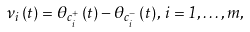Convert formula to latex. <formula><loc_0><loc_0><loc_500><loc_500>\nu _ { i } \left ( t \right ) = \theta _ { c _ { i } ^ { + } } \left ( t \right ) - \theta _ { c _ { i } ^ { - } } \left ( t \right ) , \, i = 1 , \dots , m ,</formula> 